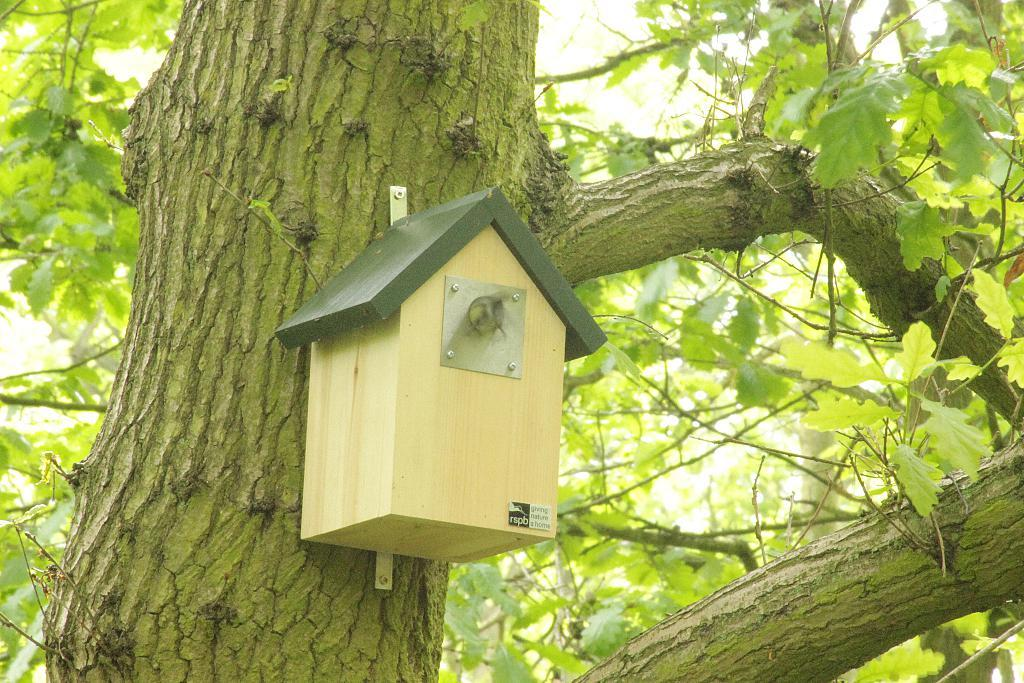What is placed on the trunk in the image? There is a model of a house on the trunk in the image. What can be seen in the background of the image? There are branches visible in the background of the image. What type of milk is being poured into the cracker in the image? There is no milk or cracker present in the image. 